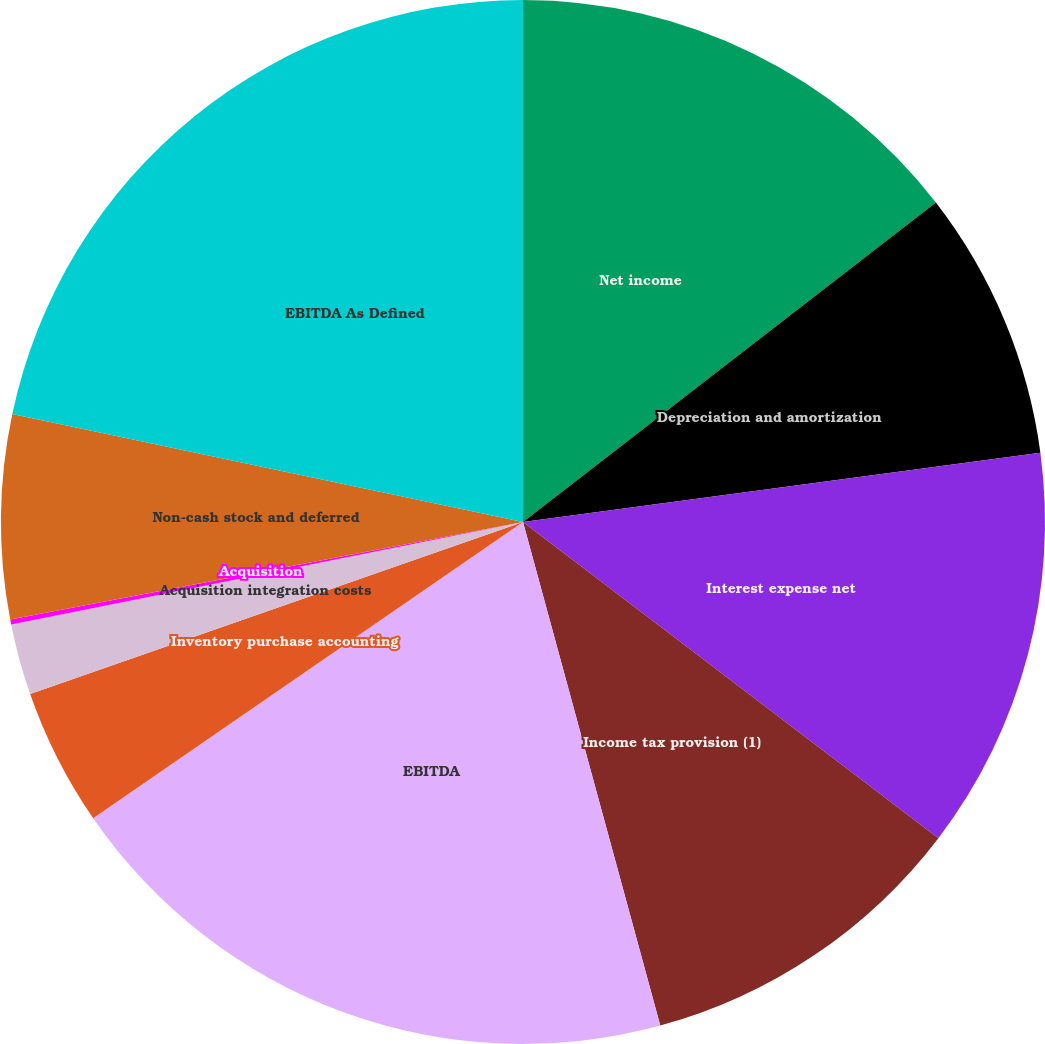Convert chart to OTSL. <chart><loc_0><loc_0><loc_500><loc_500><pie_chart><fcel>Net income<fcel>Depreciation and amortization<fcel>Interest expense net<fcel>Income tax provision (1)<fcel>EBITDA<fcel>Inventory purchase accounting<fcel>Acquisition integration costs<fcel>Acquisition<fcel>Non-cash stock and deferred<fcel>EBITDA As Defined<nl><fcel>14.52%<fcel>8.36%<fcel>12.47%<fcel>10.41%<fcel>19.63%<fcel>4.26%<fcel>2.2%<fcel>0.15%<fcel>6.31%<fcel>21.68%<nl></chart> 